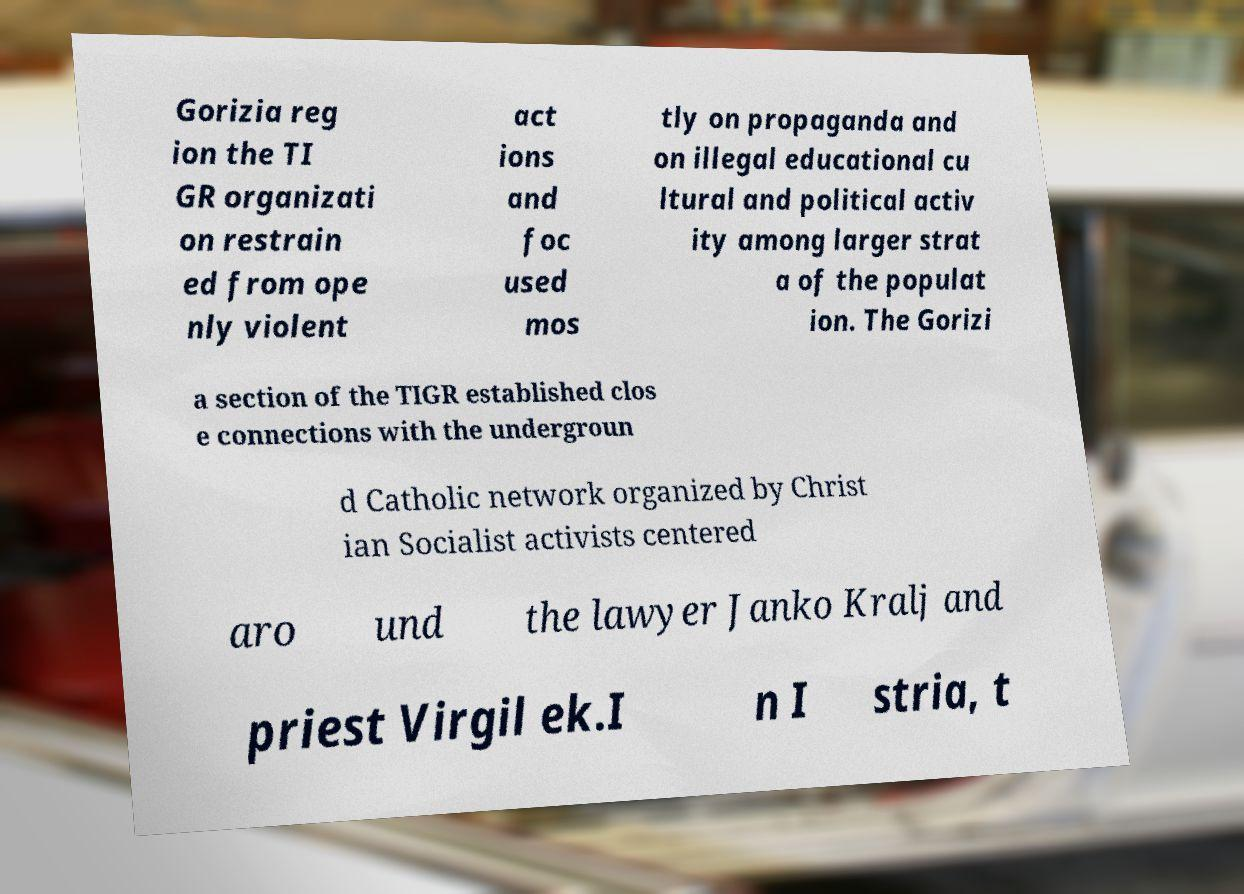Could you extract and type out the text from this image? Gorizia reg ion the TI GR organizati on restrain ed from ope nly violent act ions and foc used mos tly on propaganda and on illegal educational cu ltural and political activ ity among larger strat a of the populat ion. The Gorizi a section of the TIGR established clos e connections with the undergroun d Catholic network organized by Christ ian Socialist activists centered aro und the lawyer Janko Kralj and priest Virgil ek.I n I stria, t 